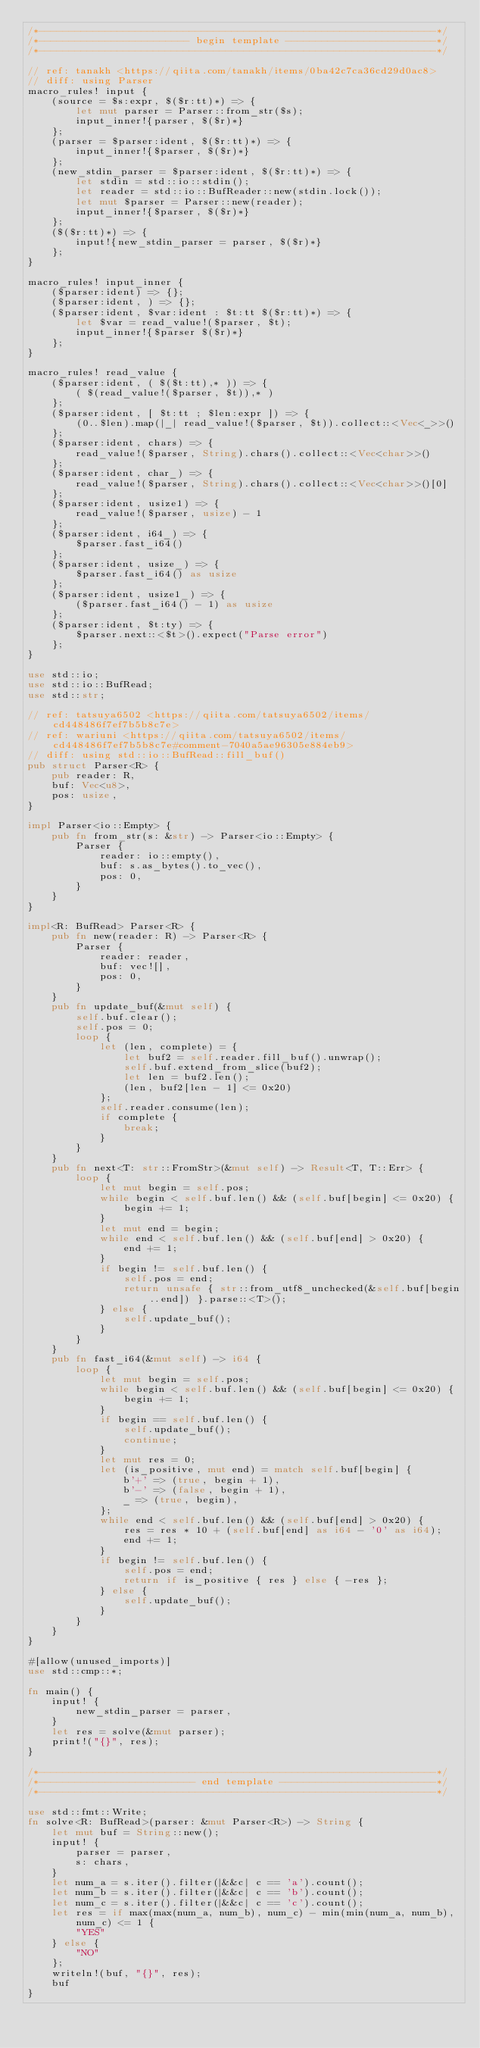Convert code to text. <code><loc_0><loc_0><loc_500><loc_500><_Rust_>/*------------------------------------------------------------------*/
/*------------------------- begin template -------------------------*/
/*------------------------------------------------------------------*/

// ref: tanakh <https://qiita.com/tanakh/items/0ba42c7ca36cd29d0ac8>
// diff: using Parser
macro_rules! input {
    (source = $s:expr, $($r:tt)*) => {
        let mut parser = Parser::from_str($s);
        input_inner!{parser, $($r)*}
    };
    (parser = $parser:ident, $($r:tt)*) => {
        input_inner!{$parser, $($r)*}
    };
    (new_stdin_parser = $parser:ident, $($r:tt)*) => {
        let stdin = std::io::stdin();
        let reader = std::io::BufReader::new(stdin.lock());
        let mut $parser = Parser::new(reader);
        input_inner!{$parser, $($r)*}
    };
    ($($r:tt)*) => {
        input!{new_stdin_parser = parser, $($r)*}
    };
}

macro_rules! input_inner {
    ($parser:ident) => {};
    ($parser:ident, ) => {};
    ($parser:ident, $var:ident : $t:tt $($r:tt)*) => {
        let $var = read_value!($parser, $t);
        input_inner!{$parser $($r)*}
    };
}

macro_rules! read_value {
    ($parser:ident, ( $($t:tt),* )) => {
        ( $(read_value!($parser, $t)),* )
    };
    ($parser:ident, [ $t:tt ; $len:expr ]) => {
        (0..$len).map(|_| read_value!($parser, $t)).collect::<Vec<_>>()
    };
    ($parser:ident, chars) => {
        read_value!($parser, String).chars().collect::<Vec<char>>()
    };
    ($parser:ident, char_) => {
        read_value!($parser, String).chars().collect::<Vec<char>>()[0]
    };
    ($parser:ident, usize1) => {
        read_value!($parser, usize) - 1
    };
    ($parser:ident, i64_) => {
        $parser.fast_i64()
    };
    ($parser:ident, usize_) => {
        $parser.fast_i64() as usize
    };
    ($parser:ident, usize1_) => {
        ($parser.fast_i64() - 1) as usize
    };
    ($parser:ident, $t:ty) => {
        $parser.next::<$t>().expect("Parse error")
    };
}

use std::io;
use std::io::BufRead;
use std::str;

// ref: tatsuya6502 <https://qiita.com/tatsuya6502/items/cd448486f7ef7b5b8c7e>
// ref: wariuni <https://qiita.com/tatsuya6502/items/cd448486f7ef7b5b8c7e#comment-7040a5ae96305e884eb9>
// diff: using std::io::BufRead::fill_buf()
pub struct Parser<R> {
    pub reader: R,
    buf: Vec<u8>,
    pos: usize,
}

impl Parser<io::Empty> {
    pub fn from_str(s: &str) -> Parser<io::Empty> {
        Parser {
            reader: io::empty(),
            buf: s.as_bytes().to_vec(),
            pos: 0,
        }
    }
}

impl<R: BufRead> Parser<R> {
    pub fn new(reader: R) -> Parser<R> {
        Parser {
            reader: reader,
            buf: vec![],
            pos: 0,
        }
    }
    pub fn update_buf(&mut self) {
        self.buf.clear();
        self.pos = 0;
        loop {
            let (len, complete) = {
                let buf2 = self.reader.fill_buf().unwrap();
                self.buf.extend_from_slice(buf2);
                let len = buf2.len();
                (len, buf2[len - 1] <= 0x20)
            };
            self.reader.consume(len);
            if complete {
                break;
            }
        }
    }
    pub fn next<T: str::FromStr>(&mut self) -> Result<T, T::Err> {
        loop {
            let mut begin = self.pos;
            while begin < self.buf.len() && (self.buf[begin] <= 0x20) {
                begin += 1;
            }
            let mut end = begin;
            while end < self.buf.len() && (self.buf[end] > 0x20) {
                end += 1;
            }
            if begin != self.buf.len() {
                self.pos = end;
                return unsafe { str::from_utf8_unchecked(&self.buf[begin..end]) }.parse::<T>();
            } else {
                self.update_buf();
            }
        }
    }
    pub fn fast_i64(&mut self) -> i64 {
        loop {
            let mut begin = self.pos;
            while begin < self.buf.len() && (self.buf[begin] <= 0x20) {
                begin += 1;
            }
            if begin == self.buf.len() {
                self.update_buf();
                continue;
            }
            let mut res = 0;
            let (is_positive, mut end) = match self.buf[begin] {
                b'+' => (true, begin + 1),
                b'-' => (false, begin + 1),
                _ => (true, begin),
            };
            while end < self.buf.len() && (self.buf[end] > 0x20) {
                res = res * 10 + (self.buf[end] as i64 - '0' as i64);
                end += 1;
            }
            if begin != self.buf.len() {
                self.pos = end;
                return if is_positive { res } else { -res };
            } else {
                self.update_buf();
            }
        }
    }
}

#[allow(unused_imports)]
use std::cmp::*;

fn main() {
    input! {
        new_stdin_parser = parser,
    }
    let res = solve(&mut parser);
    print!("{}", res);
}

/*------------------------------------------------------------------*/
/*-------------------------- end template --------------------------*/
/*------------------------------------------------------------------*/

use std::fmt::Write;
fn solve<R: BufRead>(parser: &mut Parser<R>) -> String {
    let mut buf = String::new();
    input! {
        parser = parser,
        s: chars,
    }
    let num_a = s.iter().filter(|&&c| c == 'a').count();
    let num_b = s.iter().filter(|&&c| c == 'b').count();
    let num_c = s.iter().filter(|&&c| c == 'c').count();
    let res = if max(max(num_a, num_b), num_c) - min(min(num_a, num_b), num_c) <= 1 {
        "YES"
    } else {
        "NO"
    };
    writeln!(buf, "{}", res);
    buf
}
</code> 